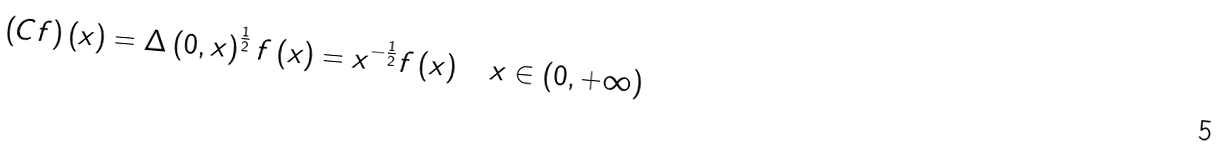Convert formula to latex. <formula><loc_0><loc_0><loc_500><loc_500>\left ( C f \right ) \left ( x \right ) = \Delta \left ( 0 , x \right ) ^ { \frac { 1 } { 2 } } f \left ( x \right ) = x ^ { - \frac { 1 } { 2 } } f \left ( x \right ) \quad x \in \left ( 0 , + \infty \right )</formula> 